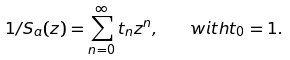<formula> <loc_0><loc_0><loc_500><loc_500>1 / S _ { a } ( z ) = \sum _ { n = 0 } ^ { \infty } t _ { n } z ^ { n } , \quad w i t h t _ { 0 } = 1 .</formula> 